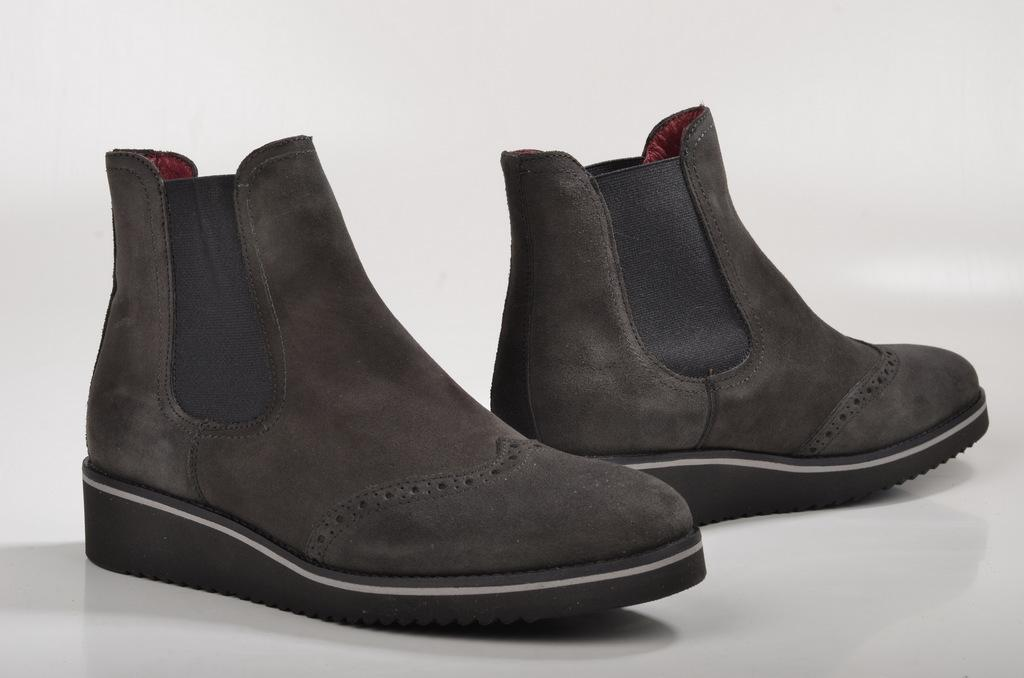What type of footwear is present in the image? There are boots in the image. What is the color of the surface on which the boots are placed? The boots are on a white surface. What type of attraction can be seen in the image? There is no attraction present in the image; it only features boots on a white surface. 